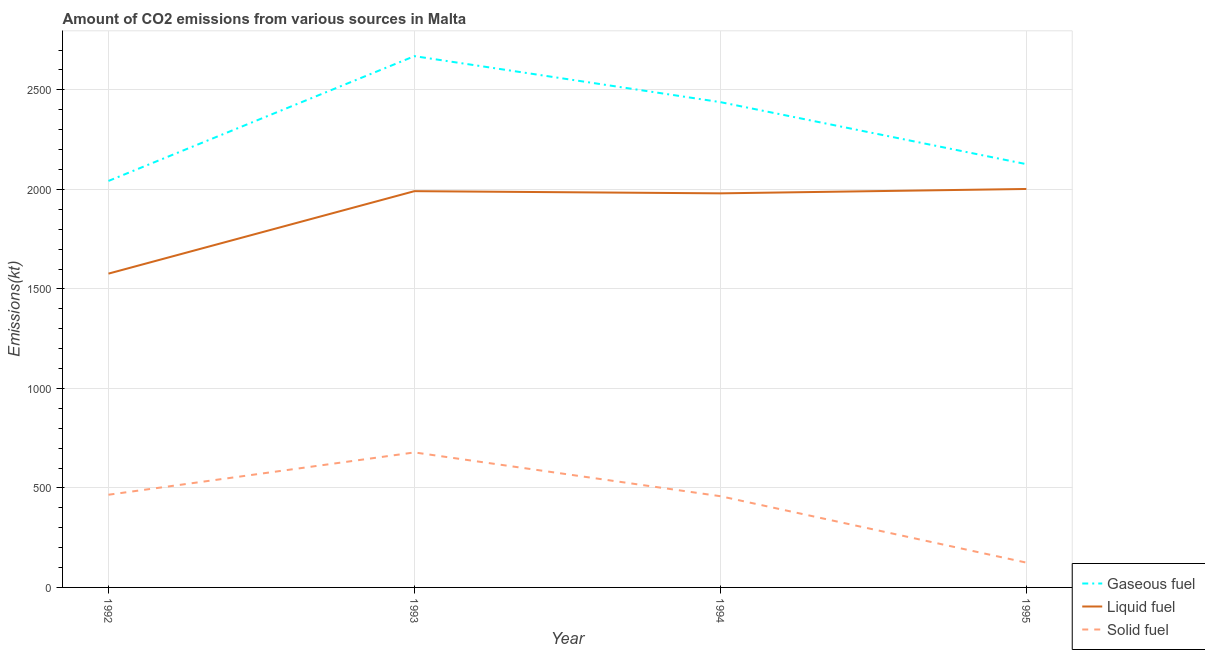How many different coloured lines are there?
Your answer should be very brief. 3. What is the amount of co2 emissions from gaseous fuel in 1992?
Make the answer very short. 2042.52. Across all years, what is the maximum amount of co2 emissions from liquid fuel?
Provide a succinct answer. 2002.18. Across all years, what is the minimum amount of co2 emissions from liquid fuel?
Your response must be concise. 1576.81. In which year was the amount of co2 emissions from gaseous fuel minimum?
Your response must be concise. 1992. What is the total amount of co2 emissions from solid fuel in the graph?
Keep it short and to the point. 1727.16. What is the difference between the amount of co2 emissions from gaseous fuel in 1992 and that in 1995?
Provide a succinct answer. -84.34. What is the difference between the amount of co2 emissions from gaseous fuel in 1994 and the amount of co2 emissions from liquid fuel in 1992?
Your answer should be compact. 861.74. What is the average amount of co2 emissions from liquid fuel per year?
Provide a succinct answer. 1887.59. In the year 1995, what is the difference between the amount of co2 emissions from liquid fuel and amount of co2 emissions from solid fuel?
Make the answer very short. 1877.5. What is the ratio of the amount of co2 emissions from liquid fuel in 1993 to that in 1995?
Ensure brevity in your answer.  0.99. Is the difference between the amount of co2 emissions from solid fuel in 1993 and 1995 greater than the difference between the amount of co2 emissions from gaseous fuel in 1993 and 1995?
Offer a terse response. Yes. What is the difference between the highest and the second highest amount of co2 emissions from liquid fuel?
Keep it short and to the point. 11. What is the difference between the highest and the lowest amount of co2 emissions from solid fuel?
Keep it short and to the point. 553.72. In how many years, is the amount of co2 emissions from gaseous fuel greater than the average amount of co2 emissions from gaseous fuel taken over all years?
Provide a short and direct response. 2. Is the sum of the amount of co2 emissions from gaseous fuel in 1992 and 1995 greater than the maximum amount of co2 emissions from solid fuel across all years?
Ensure brevity in your answer.  Yes. Is it the case that in every year, the sum of the amount of co2 emissions from gaseous fuel and amount of co2 emissions from liquid fuel is greater than the amount of co2 emissions from solid fuel?
Your answer should be very brief. Yes. Does the amount of co2 emissions from solid fuel monotonically increase over the years?
Give a very brief answer. No. Is the amount of co2 emissions from solid fuel strictly greater than the amount of co2 emissions from liquid fuel over the years?
Your answer should be compact. No. Is the amount of co2 emissions from gaseous fuel strictly less than the amount of co2 emissions from liquid fuel over the years?
Your answer should be very brief. No. How many lines are there?
Provide a succinct answer. 3. What is the difference between two consecutive major ticks on the Y-axis?
Ensure brevity in your answer.  500. Does the graph contain grids?
Provide a succinct answer. Yes. What is the title of the graph?
Your response must be concise. Amount of CO2 emissions from various sources in Malta. What is the label or title of the X-axis?
Make the answer very short. Year. What is the label or title of the Y-axis?
Ensure brevity in your answer.  Emissions(kt). What is the Emissions(kt) of Gaseous fuel in 1992?
Offer a terse response. 2042.52. What is the Emissions(kt) in Liquid fuel in 1992?
Provide a short and direct response. 1576.81. What is the Emissions(kt) in Solid fuel in 1992?
Offer a terse response. 465.71. What is the Emissions(kt) of Gaseous fuel in 1993?
Your answer should be very brief. 2669.58. What is the Emissions(kt) of Liquid fuel in 1993?
Keep it short and to the point. 1991.18. What is the Emissions(kt) in Solid fuel in 1993?
Give a very brief answer. 678.39. What is the Emissions(kt) in Gaseous fuel in 1994?
Your response must be concise. 2438.55. What is the Emissions(kt) of Liquid fuel in 1994?
Make the answer very short. 1980.18. What is the Emissions(kt) of Solid fuel in 1994?
Offer a terse response. 458.38. What is the Emissions(kt) in Gaseous fuel in 1995?
Offer a terse response. 2126.86. What is the Emissions(kt) of Liquid fuel in 1995?
Ensure brevity in your answer.  2002.18. What is the Emissions(kt) in Solid fuel in 1995?
Keep it short and to the point. 124.68. Across all years, what is the maximum Emissions(kt) of Gaseous fuel?
Make the answer very short. 2669.58. Across all years, what is the maximum Emissions(kt) in Liquid fuel?
Keep it short and to the point. 2002.18. Across all years, what is the maximum Emissions(kt) of Solid fuel?
Your answer should be very brief. 678.39. Across all years, what is the minimum Emissions(kt) in Gaseous fuel?
Offer a very short reply. 2042.52. Across all years, what is the minimum Emissions(kt) in Liquid fuel?
Your response must be concise. 1576.81. Across all years, what is the minimum Emissions(kt) in Solid fuel?
Offer a terse response. 124.68. What is the total Emissions(kt) in Gaseous fuel in the graph?
Your response must be concise. 9277.51. What is the total Emissions(kt) of Liquid fuel in the graph?
Make the answer very short. 7550.35. What is the total Emissions(kt) of Solid fuel in the graph?
Your answer should be very brief. 1727.16. What is the difference between the Emissions(kt) of Gaseous fuel in 1992 and that in 1993?
Offer a very short reply. -627.06. What is the difference between the Emissions(kt) of Liquid fuel in 1992 and that in 1993?
Ensure brevity in your answer.  -414.37. What is the difference between the Emissions(kt) in Solid fuel in 1992 and that in 1993?
Ensure brevity in your answer.  -212.69. What is the difference between the Emissions(kt) in Gaseous fuel in 1992 and that in 1994?
Your response must be concise. -396.04. What is the difference between the Emissions(kt) in Liquid fuel in 1992 and that in 1994?
Offer a terse response. -403.37. What is the difference between the Emissions(kt) in Solid fuel in 1992 and that in 1994?
Your response must be concise. 7.33. What is the difference between the Emissions(kt) of Gaseous fuel in 1992 and that in 1995?
Your response must be concise. -84.34. What is the difference between the Emissions(kt) in Liquid fuel in 1992 and that in 1995?
Ensure brevity in your answer.  -425.37. What is the difference between the Emissions(kt) of Solid fuel in 1992 and that in 1995?
Offer a very short reply. 341.03. What is the difference between the Emissions(kt) in Gaseous fuel in 1993 and that in 1994?
Keep it short and to the point. 231.02. What is the difference between the Emissions(kt) of Liquid fuel in 1993 and that in 1994?
Ensure brevity in your answer.  11. What is the difference between the Emissions(kt) of Solid fuel in 1993 and that in 1994?
Ensure brevity in your answer.  220.02. What is the difference between the Emissions(kt) of Gaseous fuel in 1993 and that in 1995?
Give a very brief answer. 542.72. What is the difference between the Emissions(kt) of Liquid fuel in 1993 and that in 1995?
Offer a very short reply. -11. What is the difference between the Emissions(kt) of Solid fuel in 1993 and that in 1995?
Offer a very short reply. 553.72. What is the difference between the Emissions(kt) of Gaseous fuel in 1994 and that in 1995?
Ensure brevity in your answer.  311.69. What is the difference between the Emissions(kt) in Liquid fuel in 1994 and that in 1995?
Offer a terse response. -22. What is the difference between the Emissions(kt) of Solid fuel in 1994 and that in 1995?
Keep it short and to the point. 333.7. What is the difference between the Emissions(kt) of Gaseous fuel in 1992 and the Emissions(kt) of Liquid fuel in 1993?
Provide a short and direct response. 51.34. What is the difference between the Emissions(kt) in Gaseous fuel in 1992 and the Emissions(kt) in Solid fuel in 1993?
Give a very brief answer. 1364.12. What is the difference between the Emissions(kt) of Liquid fuel in 1992 and the Emissions(kt) of Solid fuel in 1993?
Give a very brief answer. 898.41. What is the difference between the Emissions(kt) of Gaseous fuel in 1992 and the Emissions(kt) of Liquid fuel in 1994?
Provide a succinct answer. 62.34. What is the difference between the Emissions(kt) in Gaseous fuel in 1992 and the Emissions(kt) in Solid fuel in 1994?
Offer a very short reply. 1584.14. What is the difference between the Emissions(kt) of Liquid fuel in 1992 and the Emissions(kt) of Solid fuel in 1994?
Provide a short and direct response. 1118.43. What is the difference between the Emissions(kt) in Gaseous fuel in 1992 and the Emissions(kt) in Liquid fuel in 1995?
Make the answer very short. 40.34. What is the difference between the Emissions(kt) of Gaseous fuel in 1992 and the Emissions(kt) of Solid fuel in 1995?
Provide a succinct answer. 1917.84. What is the difference between the Emissions(kt) in Liquid fuel in 1992 and the Emissions(kt) in Solid fuel in 1995?
Offer a very short reply. 1452.13. What is the difference between the Emissions(kt) in Gaseous fuel in 1993 and the Emissions(kt) in Liquid fuel in 1994?
Offer a terse response. 689.4. What is the difference between the Emissions(kt) of Gaseous fuel in 1993 and the Emissions(kt) of Solid fuel in 1994?
Offer a terse response. 2211.2. What is the difference between the Emissions(kt) in Liquid fuel in 1993 and the Emissions(kt) in Solid fuel in 1994?
Your answer should be compact. 1532.81. What is the difference between the Emissions(kt) of Gaseous fuel in 1993 and the Emissions(kt) of Liquid fuel in 1995?
Provide a succinct answer. 667.39. What is the difference between the Emissions(kt) in Gaseous fuel in 1993 and the Emissions(kt) in Solid fuel in 1995?
Ensure brevity in your answer.  2544.9. What is the difference between the Emissions(kt) of Liquid fuel in 1993 and the Emissions(kt) of Solid fuel in 1995?
Ensure brevity in your answer.  1866.5. What is the difference between the Emissions(kt) in Gaseous fuel in 1994 and the Emissions(kt) in Liquid fuel in 1995?
Your answer should be very brief. 436.37. What is the difference between the Emissions(kt) in Gaseous fuel in 1994 and the Emissions(kt) in Solid fuel in 1995?
Offer a very short reply. 2313.88. What is the difference between the Emissions(kt) of Liquid fuel in 1994 and the Emissions(kt) of Solid fuel in 1995?
Make the answer very short. 1855.5. What is the average Emissions(kt) of Gaseous fuel per year?
Offer a terse response. 2319.38. What is the average Emissions(kt) in Liquid fuel per year?
Make the answer very short. 1887.59. What is the average Emissions(kt) of Solid fuel per year?
Your response must be concise. 431.79. In the year 1992, what is the difference between the Emissions(kt) of Gaseous fuel and Emissions(kt) of Liquid fuel?
Make the answer very short. 465.71. In the year 1992, what is the difference between the Emissions(kt) in Gaseous fuel and Emissions(kt) in Solid fuel?
Make the answer very short. 1576.81. In the year 1992, what is the difference between the Emissions(kt) of Liquid fuel and Emissions(kt) of Solid fuel?
Make the answer very short. 1111.1. In the year 1993, what is the difference between the Emissions(kt) in Gaseous fuel and Emissions(kt) in Liquid fuel?
Offer a very short reply. 678.39. In the year 1993, what is the difference between the Emissions(kt) of Gaseous fuel and Emissions(kt) of Solid fuel?
Your answer should be very brief. 1991.18. In the year 1993, what is the difference between the Emissions(kt) of Liquid fuel and Emissions(kt) of Solid fuel?
Give a very brief answer. 1312.79. In the year 1994, what is the difference between the Emissions(kt) of Gaseous fuel and Emissions(kt) of Liquid fuel?
Your answer should be compact. 458.38. In the year 1994, what is the difference between the Emissions(kt) in Gaseous fuel and Emissions(kt) in Solid fuel?
Ensure brevity in your answer.  1980.18. In the year 1994, what is the difference between the Emissions(kt) in Liquid fuel and Emissions(kt) in Solid fuel?
Ensure brevity in your answer.  1521.81. In the year 1995, what is the difference between the Emissions(kt) of Gaseous fuel and Emissions(kt) of Liquid fuel?
Your answer should be very brief. 124.68. In the year 1995, what is the difference between the Emissions(kt) of Gaseous fuel and Emissions(kt) of Solid fuel?
Your answer should be very brief. 2002.18. In the year 1995, what is the difference between the Emissions(kt) in Liquid fuel and Emissions(kt) in Solid fuel?
Provide a succinct answer. 1877.5. What is the ratio of the Emissions(kt) of Gaseous fuel in 1992 to that in 1993?
Keep it short and to the point. 0.77. What is the ratio of the Emissions(kt) of Liquid fuel in 1992 to that in 1993?
Keep it short and to the point. 0.79. What is the ratio of the Emissions(kt) of Solid fuel in 1992 to that in 1993?
Your response must be concise. 0.69. What is the ratio of the Emissions(kt) in Gaseous fuel in 1992 to that in 1994?
Offer a terse response. 0.84. What is the ratio of the Emissions(kt) in Liquid fuel in 1992 to that in 1994?
Your response must be concise. 0.8. What is the ratio of the Emissions(kt) of Solid fuel in 1992 to that in 1994?
Your answer should be compact. 1.02. What is the ratio of the Emissions(kt) in Gaseous fuel in 1992 to that in 1995?
Your response must be concise. 0.96. What is the ratio of the Emissions(kt) in Liquid fuel in 1992 to that in 1995?
Ensure brevity in your answer.  0.79. What is the ratio of the Emissions(kt) in Solid fuel in 1992 to that in 1995?
Offer a terse response. 3.74. What is the ratio of the Emissions(kt) in Gaseous fuel in 1993 to that in 1994?
Provide a short and direct response. 1.09. What is the ratio of the Emissions(kt) in Liquid fuel in 1993 to that in 1994?
Your answer should be very brief. 1.01. What is the ratio of the Emissions(kt) in Solid fuel in 1993 to that in 1994?
Make the answer very short. 1.48. What is the ratio of the Emissions(kt) in Gaseous fuel in 1993 to that in 1995?
Make the answer very short. 1.26. What is the ratio of the Emissions(kt) in Liquid fuel in 1993 to that in 1995?
Give a very brief answer. 0.99. What is the ratio of the Emissions(kt) in Solid fuel in 1993 to that in 1995?
Your response must be concise. 5.44. What is the ratio of the Emissions(kt) in Gaseous fuel in 1994 to that in 1995?
Keep it short and to the point. 1.15. What is the ratio of the Emissions(kt) of Liquid fuel in 1994 to that in 1995?
Your answer should be very brief. 0.99. What is the ratio of the Emissions(kt) of Solid fuel in 1994 to that in 1995?
Offer a very short reply. 3.68. What is the difference between the highest and the second highest Emissions(kt) of Gaseous fuel?
Your answer should be very brief. 231.02. What is the difference between the highest and the second highest Emissions(kt) in Liquid fuel?
Your answer should be compact. 11. What is the difference between the highest and the second highest Emissions(kt) in Solid fuel?
Offer a terse response. 212.69. What is the difference between the highest and the lowest Emissions(kt) of Gaseous fuel?
Ensure brevity in your answer.  627.06. What is the difference between the highest and the lowest Emissions(kt) in Liquid fuel?
Keep it short and to the point. 425.37. What is the difference between the highest and the lowest Emissions(kt) of Solid fuel?
Provide a succinct answer. 553.72. 